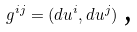<formula> <loc_0><loc_0><loc_500><loc_500>g ^ { i j } = ( d u ^ { i } , d u ^ { j } ) \text { ,}</formula> 